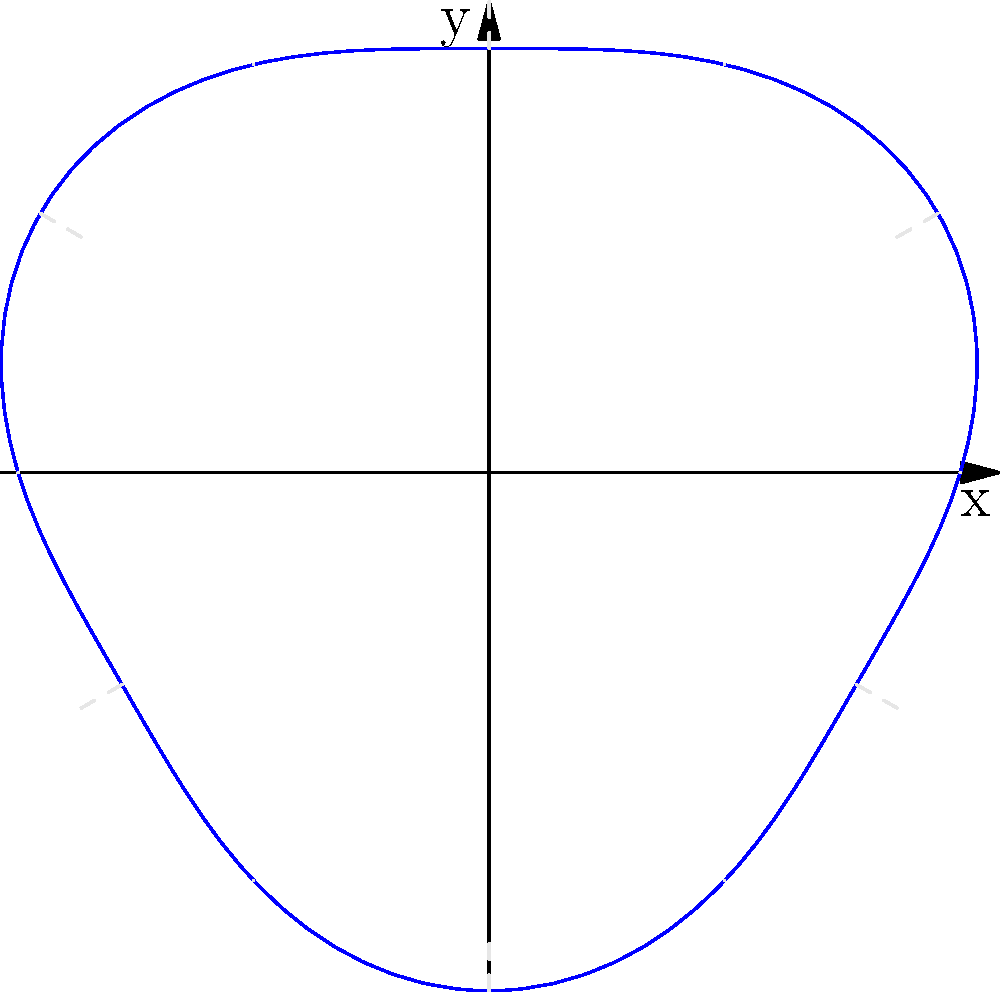The polar graph above represents the curvature of an eye's lens. The equation of the curve is given by $r(\theta) = 5 + 0.5\sin(3\theta)$, where $r$ is in millimeters. What is the maximum deviation of the lens surface from a perfect circle with radius 5 mm, and at what angle(s) does this maximum deviation occur? To solve this problem, we need to follow these steps:

1) The deviation from a perfect circle is given by the term $0.5\sin(3\theta)$ in the equation.

2) The maximum value of sine is 1, and its minimum value is -1.

3) Therefore, the maximum deviation occurs when $\sin(3\theta) = \pm 1$.

4) The magnitude of the maximum deviation is $0.5 \cdot 1 = 0.5$ mm.

5) To find the angles where this occurs, we solve:
   $\sin(3\theta) = \pm 1$

6) This occurs when $3\theta = \frac{\pi}{2}$ (for +1) or $3\theta = \frac{3\pi}{2}$ (for -1)

7) Solving for $\theta$:
   $\theta = \frac{\pi}{6}$ or $\theta = \frac{\pi}{2}$ (for maximum positive deviation)
   $\theta = \frac{5\pi}{6}$ or $\theta = \frac{3\pi}{2}$ (for maximum negative deviation)

8) Converting to degrees:
   $30°$, $90°$, $150°$, and $270°$

Therefore, the maximum deviation is 0.5 mm, occurring at angles $30°$, $90°$, $150°$, and $270°$.
Answer: 0.5 mm at $30°$, $90°$, $150°$, and $270°$ 